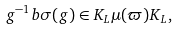<formula> <loc_0><loc_0><loc_500><loc_500>g ^ { - 1 } b \sigma ( g ) \in K _ { L } \mu ( \varpi ) K _ { L } ,</formula> 